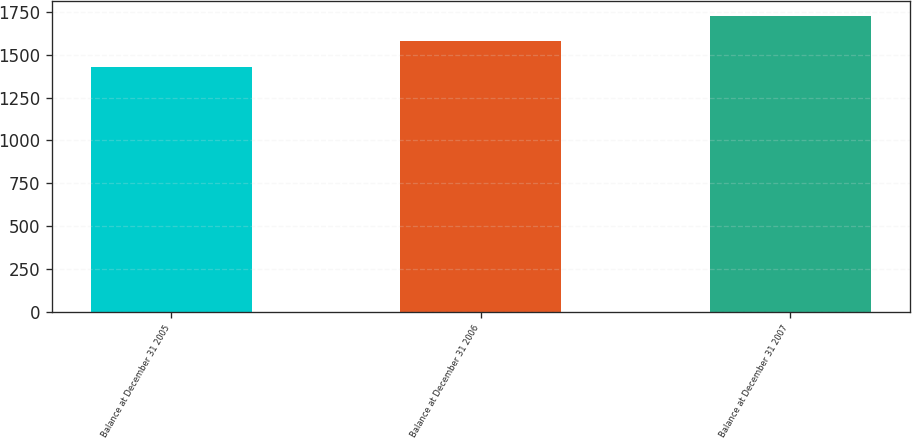<chart> <loc_0><loc_0><loc_500><loc_500><bar_chart><fcel>Balance at December 31 2005<fcel>Balance at December 31 2006<fcel>Balance at December 31 2007<nl><fcel>1426.2<fcel>1582.4<fcel>1726.3<nl></chart> 